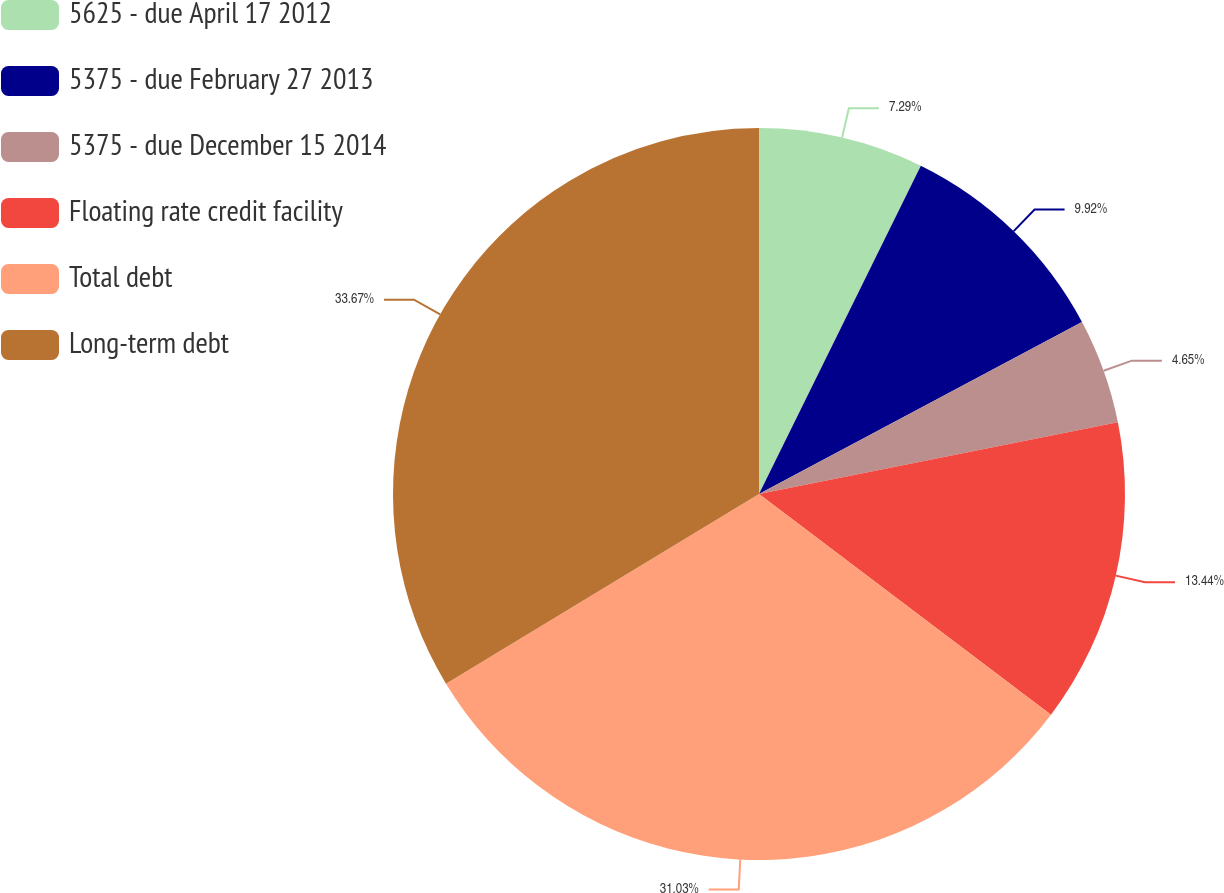Convert chart. <chart><loc_0><loc_0><loc_500><loc_500><pie_chart><fcel>5625 - due April 17 2012<fcel>5375 - due February 27 2013<fcel>5375 - due December 15 2014<fcel>Floating rate credit facility<fcel>Total debt<fcel>Long-term debt<nl><fcel>7.29%<fcel>9.92%<fcel>4.65%<fcel>13.44%<fcel>31.03%<fcel>33.67%<nl></chart> 